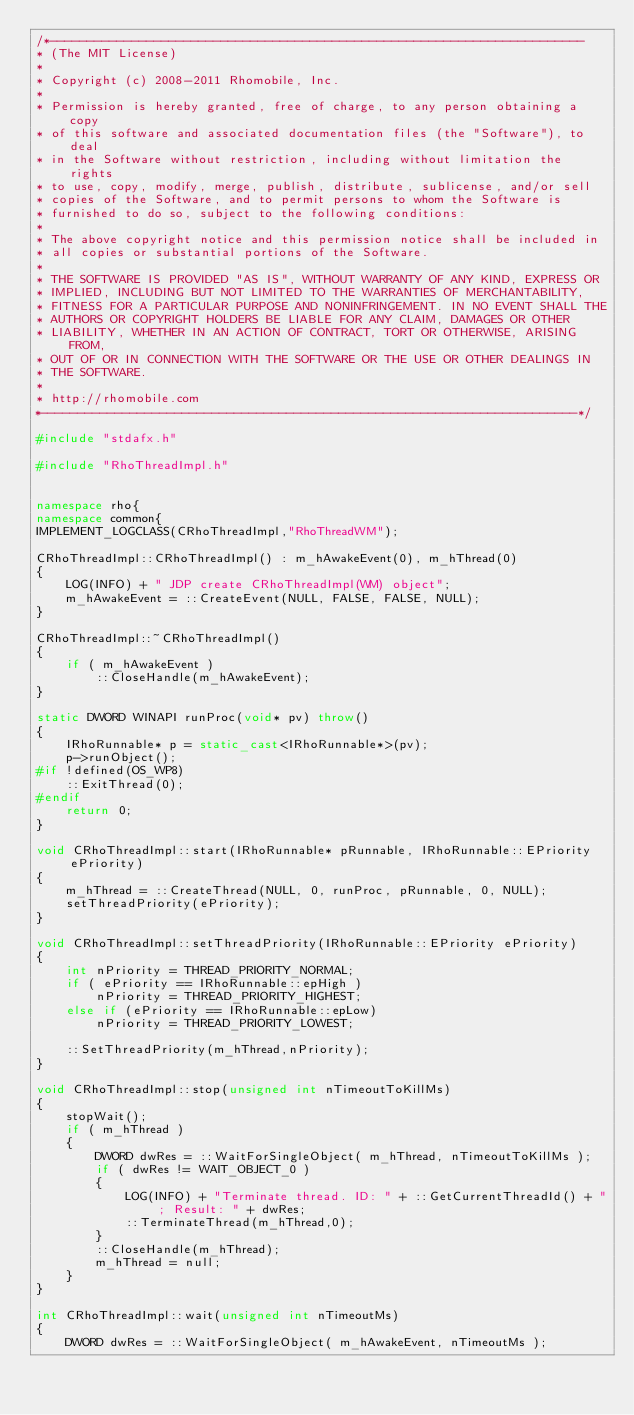Convert code to text. <code><loc_0><loc_0><loc_500><loc_500><_C++_>/*------------------------------------------------------------------------
* (The MIT License)
* 
* Copyright (c) 2008-2011 Rhomobile, Inc.
* 
* Permission is hereby granted, free of charge, to any person obtaining a copy
* of this software and associated documentation files (the "Software"), to deal
* in the Software without restriction, including without limitation the rights
* to use, copy, modify, merge, publish, distribute, sublicense, and/or sell
* copies of the Software, and to permit persons to whom the Software is
* furnished to do so, subject to the following conditions:
* 
* The above copyright notice and this permission notice shall be included in
* all copies or substantial portions of the Software.
* 
* THE SOFTWARE IS PROVIDED "AS IS", WITHOUT WARRANTY OF ANY KIND, EXPRESS OR
* IMPLIED, INCLUDING BUT NOT LIMITED TO THE WARRANTIES OF MERCHANTABILITY,
* FITNESS FOR A PARTICULAR PURPOSE AND NONINFRINGEMENT. IN NO EVENT SHALL THE
* AUTHORS OR COPYRIGHT HOLDERS BE LIABLE FOR ANY CLAIM, DAMAGES OR OTHER
* LIABILITY, WHETHER IN AN ACTION OF CONTRACT, TORT OR OTHERWISE, ARISING FROM,
* OUT OF OR IN CONNECTION WITH THE SOFTWARE OR THE USE OR OTHER DEALINGS IN
* THE SOFTWARE.
* 
* http://rhomobile.com
*------------------------------------------------------------------------*/

#include "stdafx.h"

#include "RhoThreadImpl.h"


namespace rho{
namespace common{
IMPLEMENT_LOGCLASS(CRhoThreadImpl,"RhoThreadWM");

CRhoThreadImpl::CRhoThreadImpl() : m_hAwakeEvent(0), m_hThread(0)
{
	LOG(INFO) + " JDP create CRhoThreadImpl(WM) object";
	m_hAwakeEvent = ::CreateEvent(NULL, FALSE, FALSE, NULL);
}

CRhoThreadImpl::~CRhoThreadImpl()
{
    if ( m_hAwakeEvent )
        ::CloseHandle(m_hAwakeEvent);
}

static DWORD WINAPI runProc(void* pv) throw()
{
	IRhoRunnable* p = static_cast<IRhoRunnable*>(pv);
	p->runObject();
#if !defined(OS_WP8)
    ::ExitThread(0);
#endif
	return 0;
}

void CRhoThreadImpl::start(IRhoRunnable* pRunnable, IRhoRunnable::EPriority ePriority)
{
    m_hThread = ::CreateThread(NULL, 0, runProc, pRunnable, 0, NULL);
    setThreadPriority(ePriority);
}

void CRhoThreadImpl::setThreadPriority(IRhoRunnable::EPriority ePriority)
{
    int nPriority = THREAD_PRIORITY_NORMAL;
    if ( ePriority == IRhoRunnable::epHigh )
        nPriority = THREAD_PRIORITY_HIGHEST;
    else if (ePriority == IRhoRunnable::epLow)
        nPriority = THREAD_PRIORITY_LOWEST;

    ::SetThreadPriority(m_hThread,nPriority);
}

void CRhoThreadImpl::stop(unsigned int nTimeoutToKillMs)
{
    stopWait();
    if ( m_hThread )
    {
        DWORD dwRes = ::WaitForSingleObject( m_hThread, nTimeoutToKillMs );
        if ( dwRes != WAIT_OBJECT_0 )
        {
            LOG(INFO) + "Terminate thread. ID: " + ::GetCurrentThreadId() + "; Result: " + dwRes;
            ::TerminateThread(m_hThread,0);
        }
        ::CloseHandle(m_hThread);
        m_hThread = null;
    }
}

int CRhoThreadImpl::wait(unsigned int nTimeoutMs)
{
    DWORD dwRes = ::WaitForSingleObject( m_hAwakeEvent, nTimeoutMs );</code> 